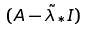<formula> <loc_0><loc_0><loc_500><loc_500>( A - \tilde { \lambda } _ { * } I )</formula> 